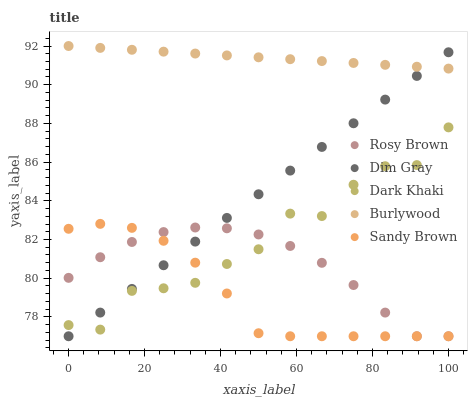Does Sandy Brown have the minimum area under the curve?
Answer yes or no. Yes. Does Burlywood have the maximum area under the curve?
Answer yes or no. Yes. Does Dim Gray have the minimum area under the curve?
Answer yes or no. No. Does Dim Gray have the maximum area under the curve?
Answer yes or no. No. Is Burlywood the smoothest?
Answer yes or no. Yes. Is Dark Khaki the roughest?
Answer yes or no. Yes. Is Dim Gray the smoothest?
Answer yes or no. No. Is Dim Gray the roughest?
Answer yes or no. No. Does Dim Gray have the lowest value?
Answer yes or no. Yes. Does Burlywood have the lowest value?
Answer yes or no. No. Does Burlywood have the highest value?
Answer yes or no. Yes. Does Dim Gray have the highest value?
Answer yes or no. No. Is Dark Khaki less than Burlywood?
Answer yes or no. Yes. Is Burlywood greater than Dark Khaki?
Answer yes or no. Yes. Does Dark Khaki intersect Sandy Brown?
Answer yes or no. Yes. Is Dark Khaki less than Sandy Brown?
Answer yes or no. No. Is Dark Khaki greater than Sandy Brown?
Answer yes or no. No. Does Dark Khaki intersect Burlywood?
Answer yes or no. No. 